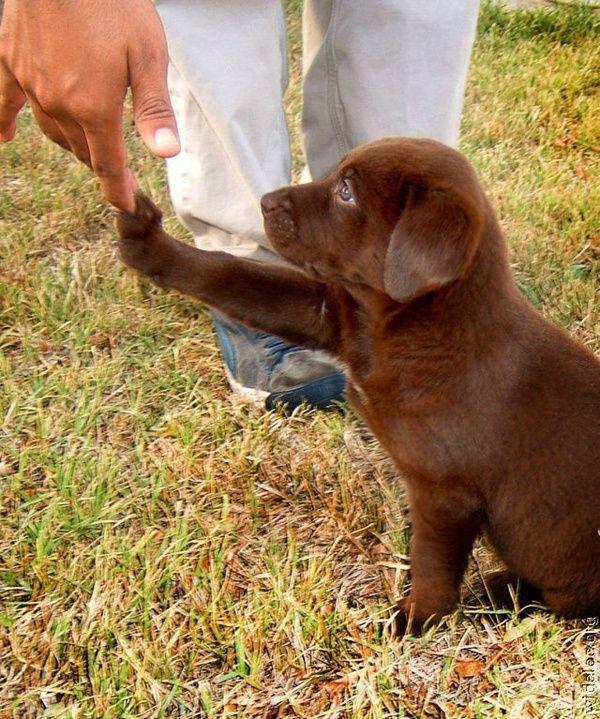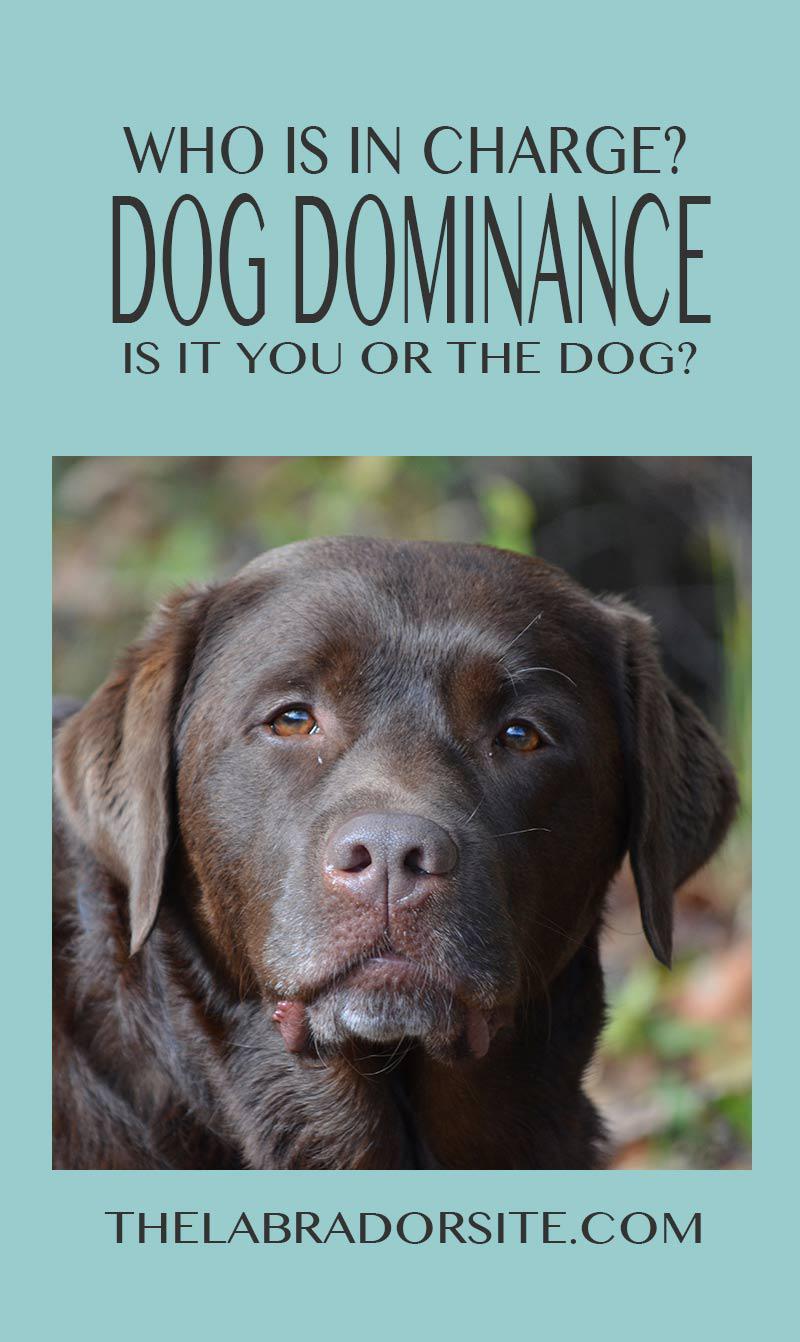The first image is the image on the left, the second image is the image on the right. Evaluate the accuracy of this statement regarding the images: "One image shows a lone dog facing the right with his mouth open.". Is it true? Answer yes or no. No. The first image is the image on the left, the second image is the image on the right. Assess this claim about the two images: "There is at least one human touching a dog.". Correct or not? Answer yes or no. Yes. 